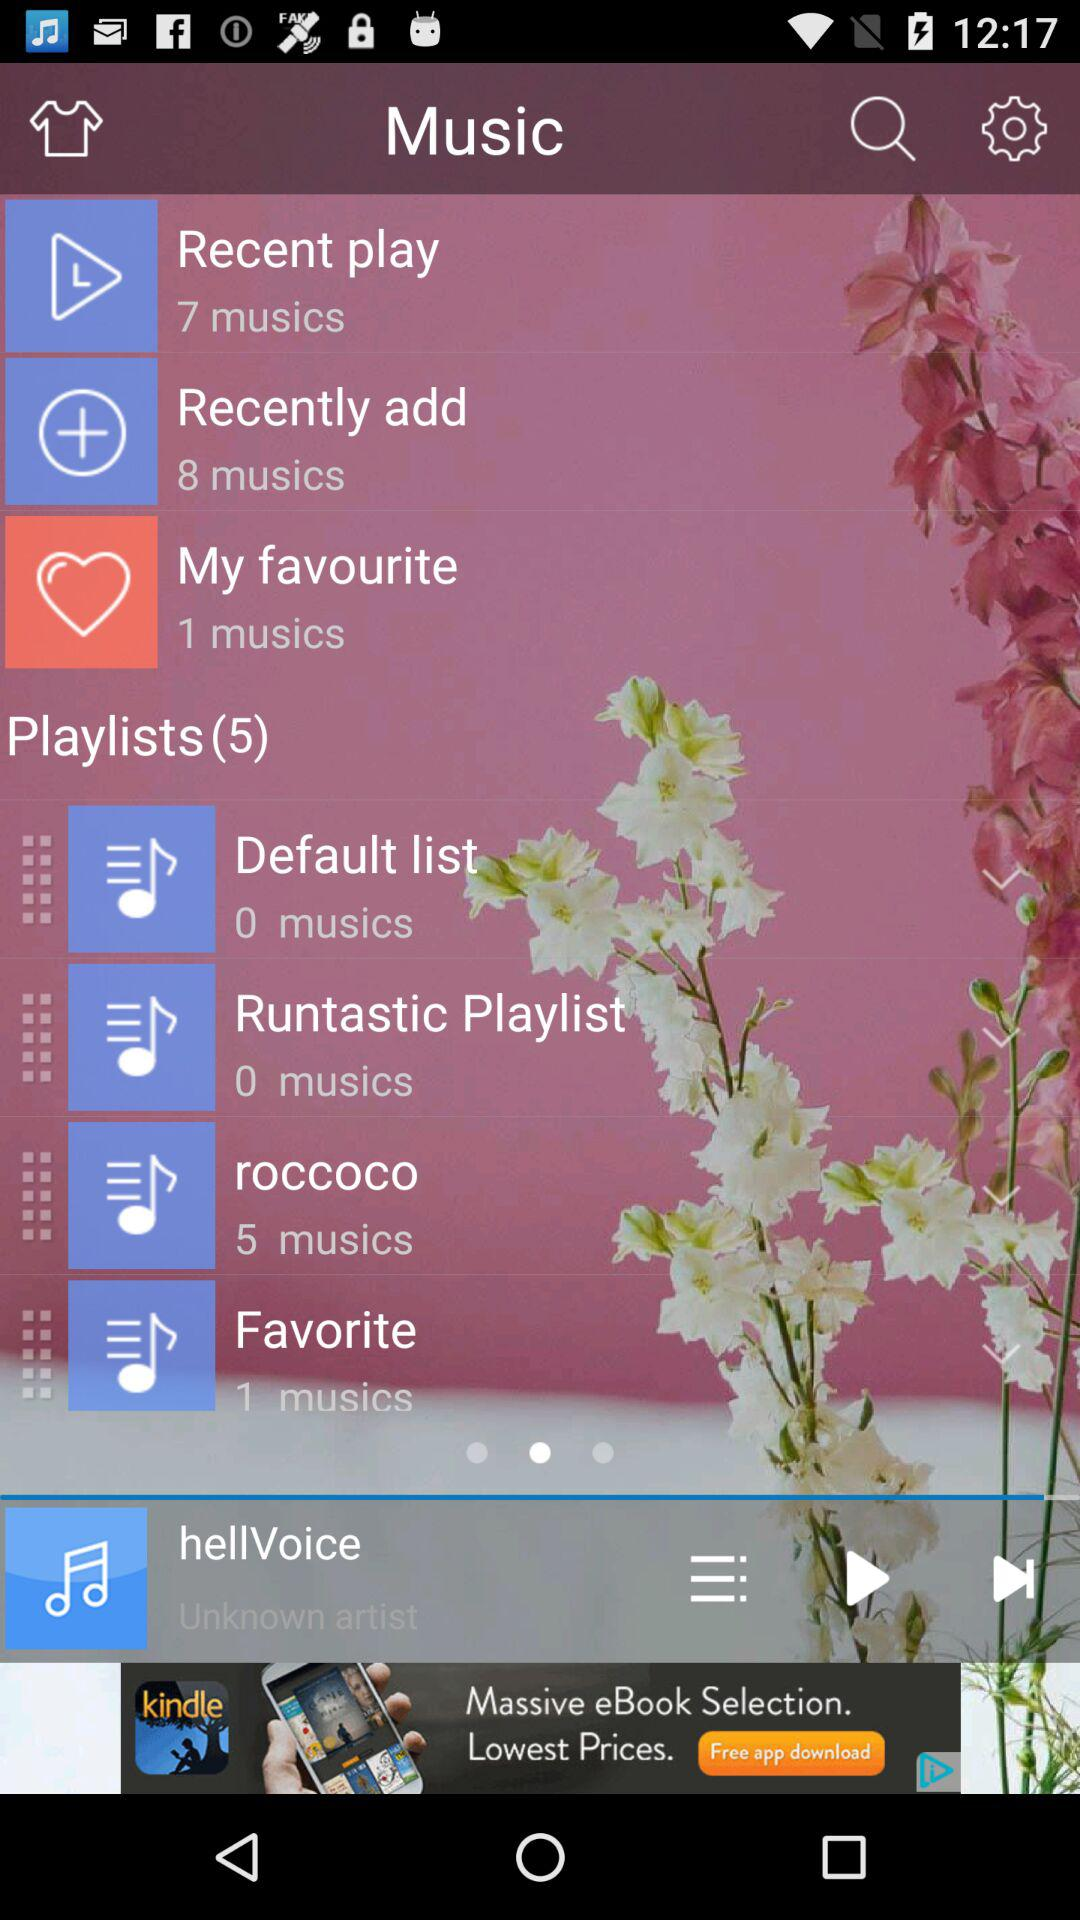How many playlists are there? There are 5 playlists. 